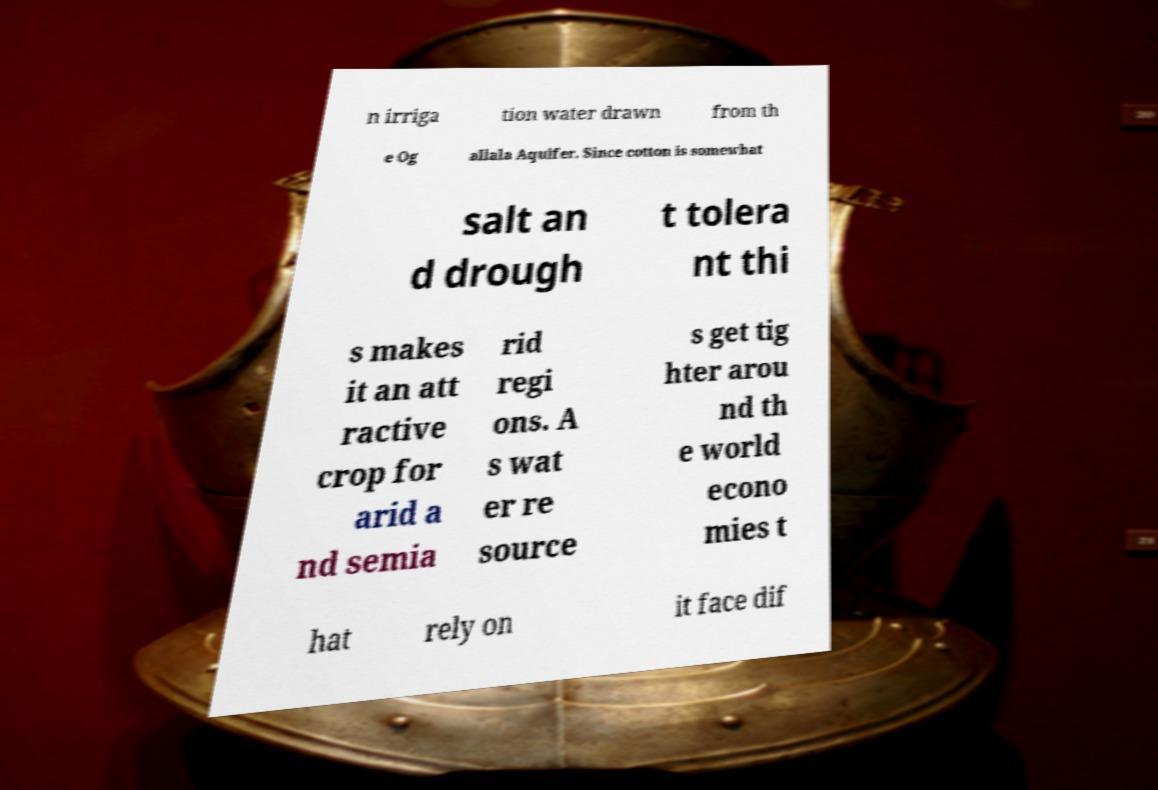I need the written content from this picture converted into text. Can you do that? n irriga tion water drawn from th e Og allala Aquifer. Since cotton is somewhat salt an d drough t tolera nt thi s makes it an att ractive crop for arid a nd semia rid regi ons. A s wat er re source s get tig hter arou nd th e world econo mies t hat rely on it face dif 